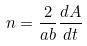Convert formula to latex. <formula><loc_0><loc_0><loc_500><loc_500>n = \frac { 2 } { a b } \frac { d A } { d t }</formula> 